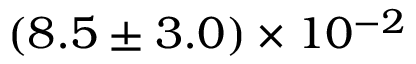Convert formula to latex. <formula><loc_0><loc_0><loc_500><loc_500>( 8 . 5 \pm 3 . 0 ) \times 1 0 ^ { - 2 }</formula> 